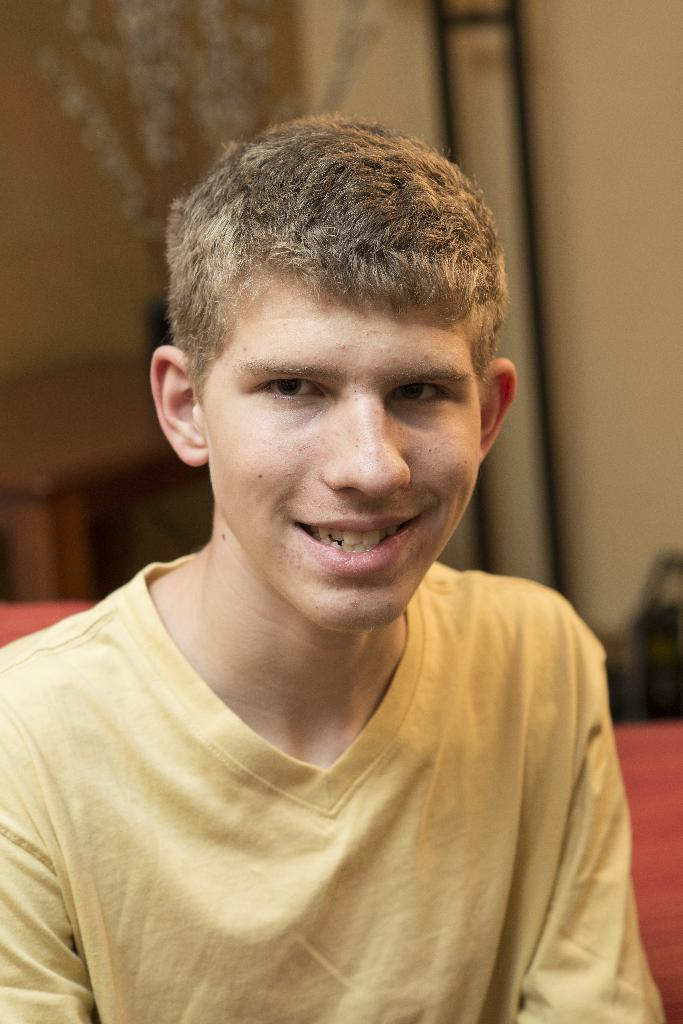Who is present in the image? There is a man in the image. What is the man doing in the image? The man is looking to his side. What is the man wearing in the image? The man is wearing a yellow t-shirt. What can be seen on the right side of the image? There is a wall on the right side of the image. What type of baby is sitting on the throne in the image? There is no baby or throne present in the image; it features a man wearing a yellow t-shirt and looking to his side. 